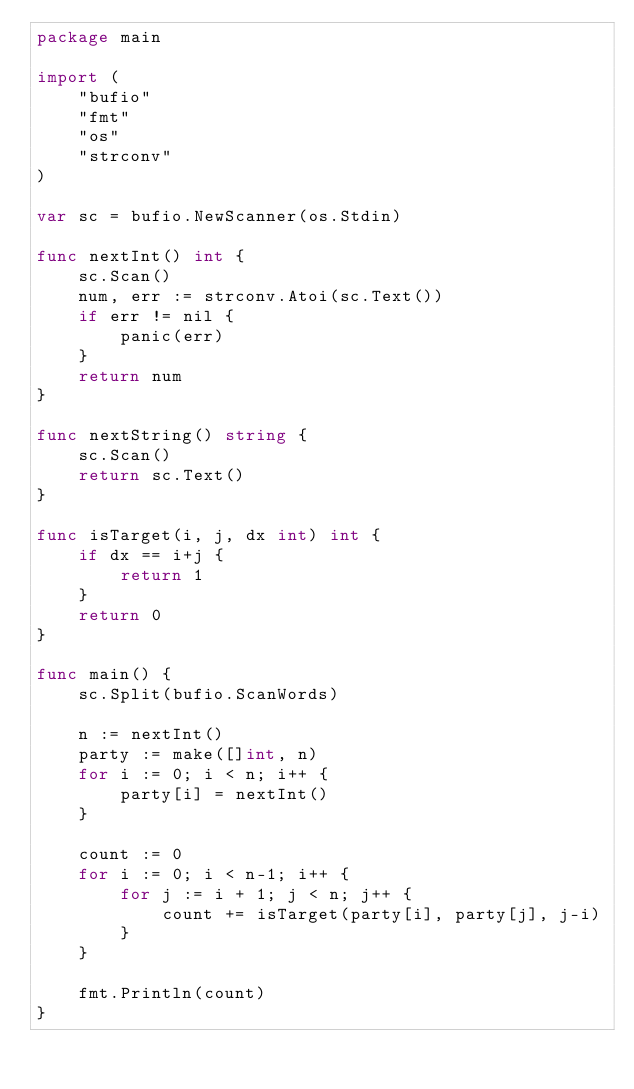Convert code to text. <code><loc_0><loc_0><loc_500><loc_500><_Go_>package main

import (
	"bufio"
	"fmt"
	"os"
	"strconv"
)

var sc = bufio.NewScanner(os.Stdin)

func nextInt() int {
	sc.Scan()
	num, err := strconv.Atoi(sc.Text())
	if err != nil {
		panic(err)
	}
	return num
}

func nextString() string {
	sc.Scan()
	return sc.Text()
}

func isTarget(i, j, dx int) int {
	if dx == i+j {
		return 1
	}
	return 0
}

func main() {
	sc.Split(bufio.ScanWords)

	n := nextInt()
	party := make([]int, n)
	for i := 0; i < n; i++ {
		party[i] = nextInt()
	}

	count := 0
	for i := 0; i < n-1; i++ {
		for j := i + 1; j < n; j++ {
			count += isTarget(party[i], party[j], j-i)
		}
	}

	fmt.Println(count)
}
</code> 